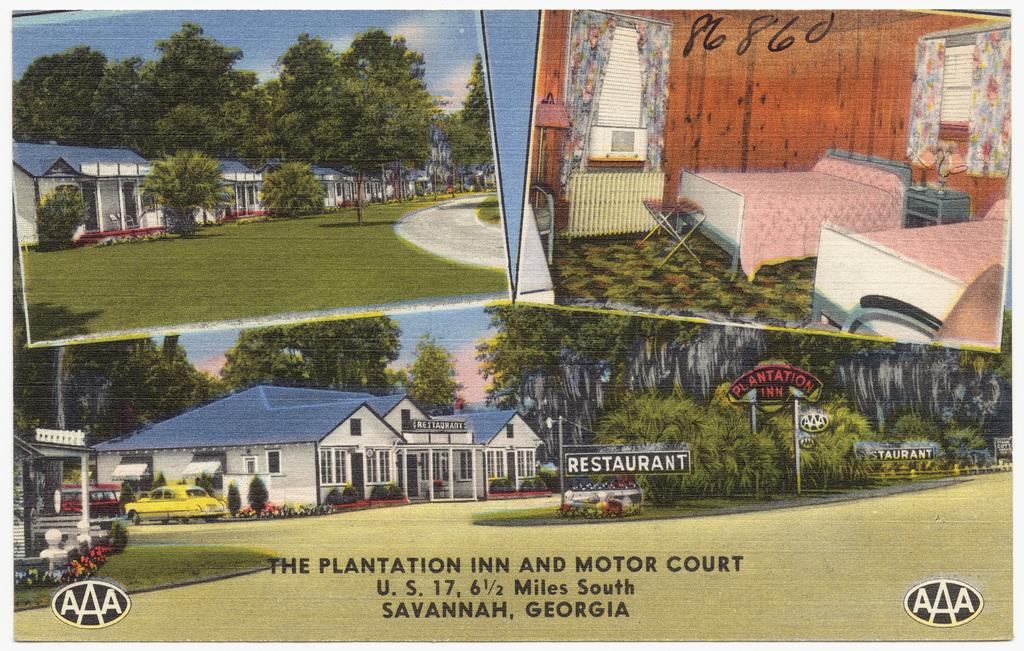What type of picture is in the image? There is a collage picture in the image. What kind of images can be found in the collage? The collage picture contains images of buildings, trees, roads, the ground, motor vehicles, cots, side tables, bed lamps, and curtains. Are there any images of appliances in the collage? Yes, there are images of air conditioners in the collage. What type of competition is being held in the image? There is no competition present in the image; it features a collage picture with various images. What color is the shade in the image? There is no shade present in the image; it contains a collage with images of buildings, trees, roads, and other objects. 